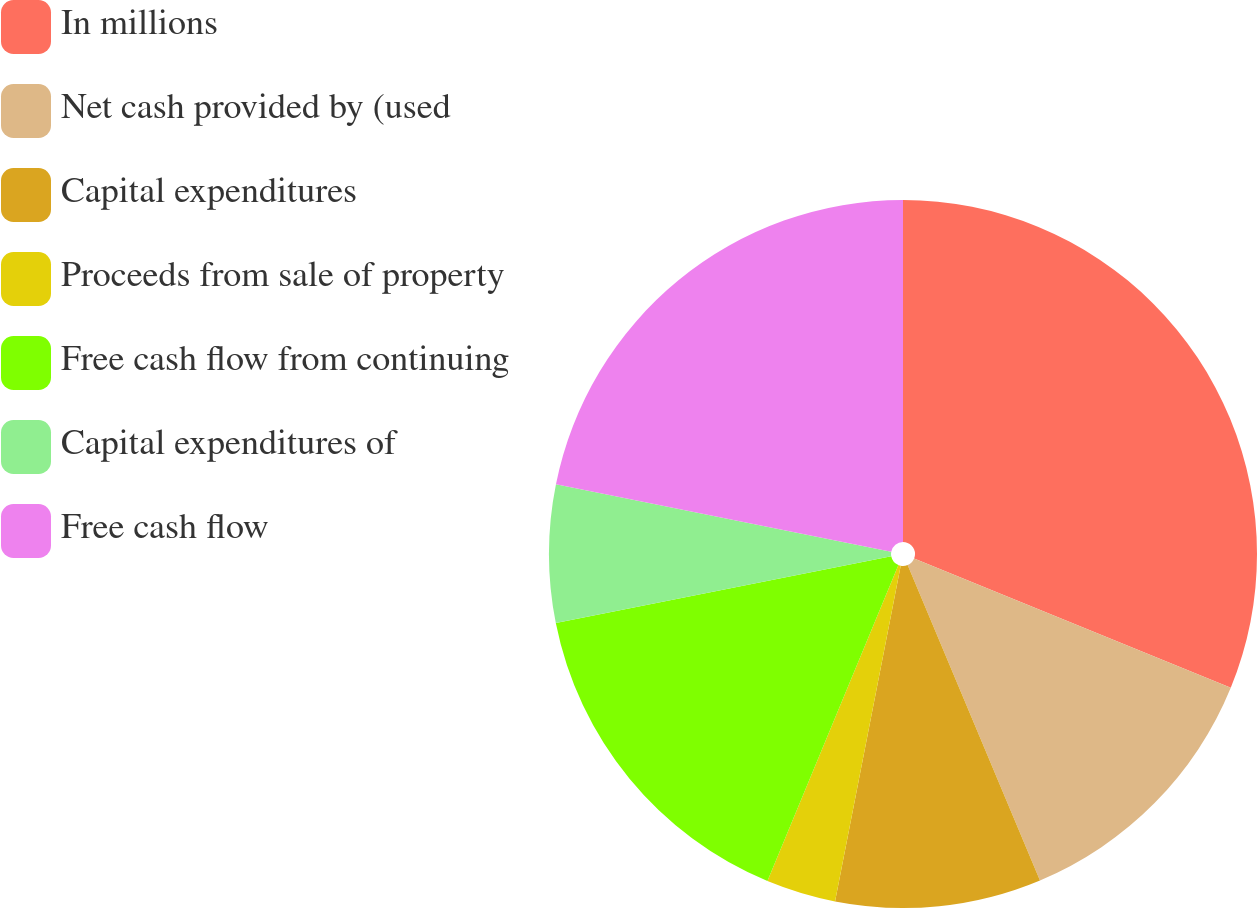<chart> <loc_0><loc_0><loc_500><loc_500><pie_chart><fcel>In millions<fcel>Net cash provided by (used<fcel>Capital expenditures<fcel>Proceeds from sale of property<fcel>Free cash flow from continuing<fcel>Capital expenditures of<fcel>Free cash flow<nl><fcel>31.17%<fcel>12.51%<fcel>9.4%<fcel>3.18%<fcel>15.62%<fcel>6.29%<fcel>21.84%<nl></chart> 